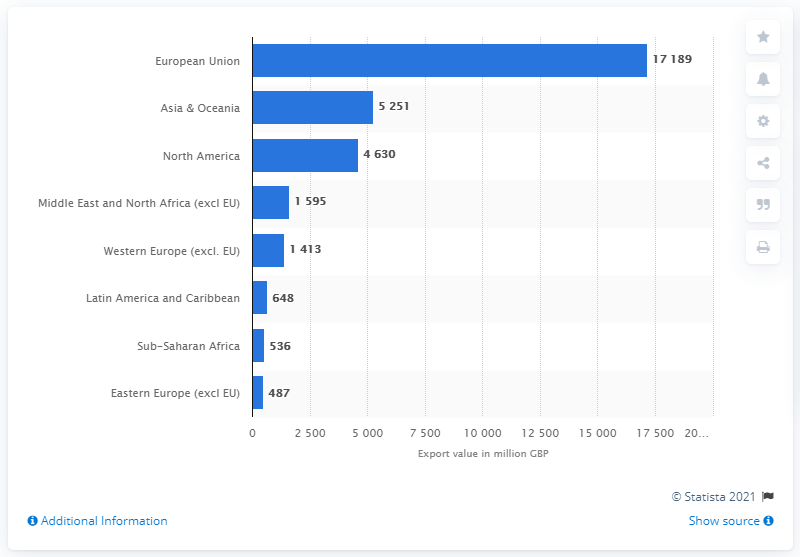Mention a couple of crucial points in this snapshot. Scotland's second largest export market was Asia and Oceania. 